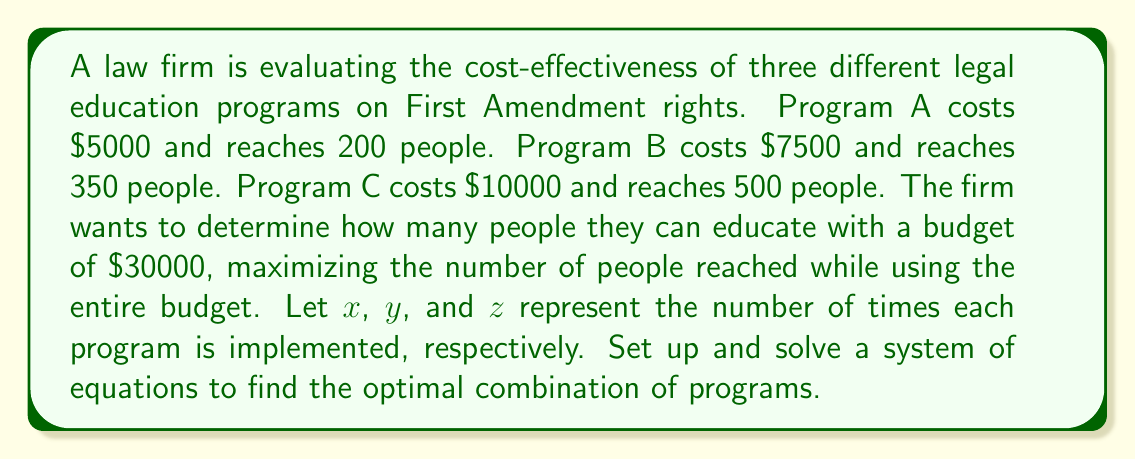Could you help me with this problem? To solve this problem, we need to set up a system of equations based on the given information:

1. Budget constraint equation:
   $5000x + 7500y + 10000z = 30000$

2. Maximize the number of people reached:
   $200x + 350y + 500z = P$ (where P is the total number of people reached)

3. Non-negative integer constraint:
   $x, y, z \geq 0$ and $x, y, z$ are integers

We can simplify the first equation by dividing all terms by 2500:
$2x + 3y + 4z = 12$

Now, we need to find integer values for $x$, $y$, and $z$ that satisfy this equation and maximize $P$.

By inspection or trial and error, we can find that $x = 3$, $y = 2$, and $z = 0$ satisfies the equation:
$2(3) + 3(2) + 4(0) = 6 + 6 + 0 = 12$

To verify this is the optimal solution, we can calculate $P$:
$P = 200(3) + 350(2) + 500(0) = 600 + 700 + 0 = 1300$

We can check that no other combination of non-negative integers yields a higher value for $P$ while still satisfying the budget constraint.
Answer: The optimal combination is to implement Program A three times and Program B twice, reaching a total of 1300 people with the $30000 budget. 